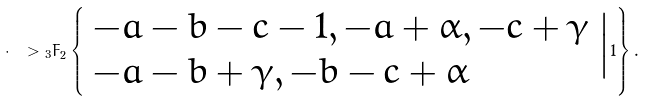<formula> <loc_0><loc_0><loc_500><loc_500>\cdot \ > { _ { 3 } F } _ { 2 } \left \{ \begin{array} { l } - a - b - c - 1 , - a + \alpha , - c + \gamma \\ - a - b + \gamma , - b - c + \alpha \\ \end{array} \Big | 1 \right \} .</formula> 